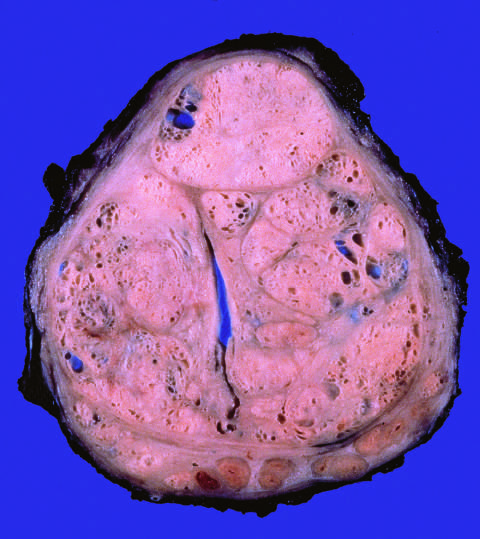what do well-defined nodules compress?
Answer the question using a single word or phrase. The urethra into a slitlike lumen 